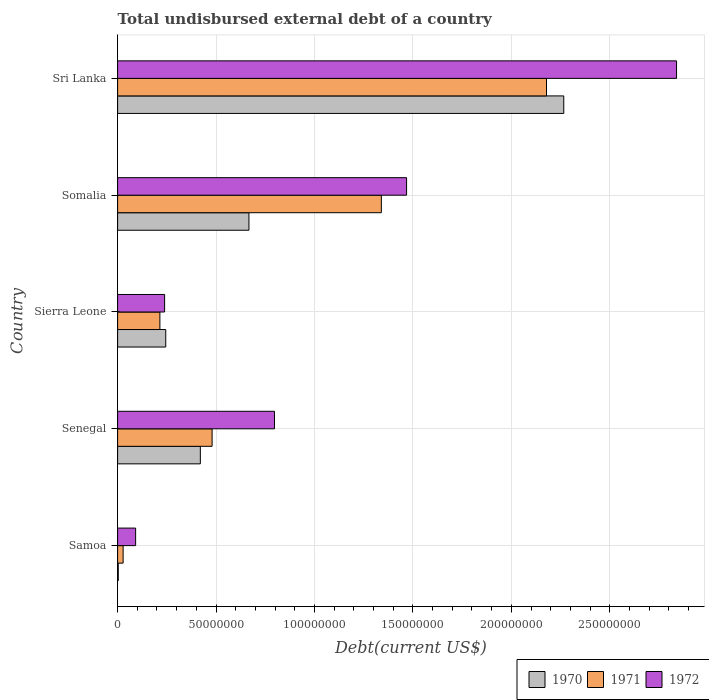How many different coloured bars are there?
Offer a terse response. 3. How many groups of bars are there?
Keep it short and to the point. 5. Are the number of bars per tick equal to the number of legend labels?
Give a very brief answer. Yes. Are the number of bars on each tick of the Y-axis equal?
Your answer should be compact. Yes. How many bars are there on the 5th tick from the top?
Ensure brevity in your answer.  3. What is the label of the 2nd group of bars from the top?
Offer a very short reply. Somalia. What is the total undisbursed external debt in 1970 in Samoa?
Your answer should be compact. 3.36e+05. Across all countries, what is the maximum total undisbursed external debt in 1971?
Provide a succinct answer. 2.18e+08. Across all countries, what is the minimum total undisbursed external debt in 1972?
Make the answer very short. 9.15e+06. In which country was the total undisbursed external debt in 1970 maximum?
Provide a short and direct response. Sri Lanka. In which country was the total undisbursed external debt in 1970 minimum?
Provide a succinct answer. Samoa. What is the total total undisbursed external debt in 1971 in the graph?
Offer a terse response. 4.24e+08. What is the difference between the total undisbursed external debt in 1970 in Samoa and that in Somalia?
Make the answer very short. -6.64e+07. What is the difference between the total undisbursed external debt in 1971 in Somalia and the total undisbursed external debt in 1972 in Senegal?
Provide a short and direct response. 5.43e+07. What is the average total undisbursed external debt in 1970 per country?
Provide a short and direct response. 7.20e+07. What is the difference between the total undisbursed external debt in 1971 and total undisbursed external debt in 1972 in Somalia?
Provide a short and direct response. -1.28e+07. In how many countries, is the total undisbursed external debt in 1971 greater than 170000000 US$?
Ensure brevity in your answer.  1. What is the ratio of the total undisbursed external debt in 1971 in Senegal to that in Sri Lanka?
Ensure brevity in your answer.  0.22. Is the total undisbursed external debt in 1971 in Samoa less than that in Sierra Leone?
Keep it short and to the point. Yes. Is the difference between the total undisbursed external debt in 1971 in Senegal and Sierra Leone greater than the difference between the total undisbursed external debt in 1972 in Senegal and Sierra Leone?
Ensure brevity in your answer.  No. What is the difference between the highest and the second highest total undisbursed external debt in 1972?
Keep it short and to the point. 1.37e+08. What is the difference between the highest and the lowest total undisbursed external debt in 1971?
Your answer should be compact. 2.15e+08. Is the sum of the total undisbursed external debt in 1970 in Samoa and Senegal greater than the maximum total undisbursed external debt in 1971 across all countries?
Provide a succinct answer. No. Is it the case that in every country, the sum of the total undisbursed external debt in 1970 and total undisbursed external debt in 1972 is greater than the total undisbursed external debt in 1971?
Ensure brevity in your answer.  Yes. How many countries are there in the graph?
Provide a succinct answer. 5. What is the difference between two consecutive major ticks on the X-axis?
Your answer should be very brief. 5.00e+07. Does the graph contain any zero values?
Your answer should be very brief. No. Does the graph contain grids?
Your answer should be compact. Yes. How many legend labels are there?
Give a very brief answer. 3. What is the title of the graph?
Give a very brief answer. Total undisbursed external debt of a country. What is the label or title of the X-axis?
Offer a terse response. Debt(current US$). What is the label or title of the Y-axis?
Provide a short and direct response. Country. What is the Debt(current US$) in 1970 in Samoa?
Your answer should be compact. 3.36e+05. What is the Debt(current US$) in 1971 in Samoa?
Your response must be concise. 2.80e+06. What is the Debt(current US$) in 1972 in Samoa?
Give a very brief answer. 9.15e+06. What is the Debt(current US$) in 1970 in Senegal?
Keep it short and to the point. 4.20e+07. What is the Debt(current US$) in 1971 in Senegal?
Make the answer very short. 4.80e+07. What is the Debt(current US$) in 1972 in Senegal?
Provide a succinct answer. 7.97e+07. What is the Debt(current US$) of 1970 in Sierra Leone?
Provide a succinct answer. 2.45e+07. What is the Debt(current US$) of 1971 in Sierra Leone?
Your answer should be very brief. 2.15e+07. What is the Debt(current US$) of 1972 in Sierra Leone?
Your answer should be very brief. 2.39e+07. What is the Debt(current US$) of 1970 in Somalia?
Offer a terse response. 6.67e+07. What is the Debt(current US$) in 1971 in Somalia?
Offer a very short reply. 1.34e+08. What is the Debt(current US$) in 1972 in Somalia?
Make the answer very short. 1.47e+08. What is the Debt(current US$) of 1970 in Sri Lanka?
Your response must be concise. 2.27e+08. What is the Debt(current US$) of 1971 in Sri Lanka?
Keep it short and to the point. 2.18e+08. What is the Debt(current US$) of 1972 in Sri Lanka?
Provide a short and direct response. 2.84e+08. Across all countries, what is the maximum Debt(current US$) of 1970?
Offer a terse response. 2.27e+08. Across all countries, what is the maximum Debt(current US$) of 1971?
Ensure brevity in your answer.  2.18e+08. Across all countries, what is the maximum Debt(current US$) of 1972?
Provide a short and direct response. 2.84e+08. Across all countries, what is the minimum Debt(current US$) in 1970?
Your answer should be very brief. 3.36e+05. Across all countries, what is the minimum Debt(current US$) in 1971?
Your answer should be very brief. 2.80e+06. Across all countries, what is the minimum Debt(current US$) in 1972?
Offer a terse response. 9.15e+06. What is the total Debt(current US$) of 1970 in the graph?
Ensure brevity in your answer.  3.60e+08. What is the total Debt(current US$) of 1971 in the graph?
Provide a succinct answer. 4.24e+08. What is the total Debt(current US$) in 1972 in the graph?
Offer a terse response. 5.43e+08. What is the difference between the Debt(current US$) in 1970 in Samoa and that in Senegal?
Offer a terse response. -4.17e+07. What is the difference between the Debt(current US$) in 1971 in Samoa and that in Senegal?
Provide a succinct answer. -4.52e+07. What is the difference between the Debt(current US$) of 1972 in Samoa and that in Senegal?
Your answer should be compact. -7.05e+07. What is the difference between the Debt(current US$) in 1970 in Samoa and that in Sierra Leone?
Give a very brief answer. -2.41e+07. What is the difference between the Debt(current US$) of 1971 in Samoa and that in Sierra Leone?
Ensure brevity in your answer.  -1.87e+07. What is the difference between the Debt(current US$) in 1972 in Samoa and that in Sierra Leone?
Offer a very short reply. -1.47e+07. What is the difference between the Debt(current US$) in 1970 in Samoa and that in Somalia?
Provide a short and direct response. -6.64e+07. What is the difference between the Debt(current US$) in 1971 in Samoa and that in Somalia?
Provide a succinct answer. -1.31e+08. What is the difference between the Debt(current US$) in 1972 in Samoa and that in Somalia?
Ensure brevity in your answer.  -1.38e+08. What is the difference between the Debt(current US$) in 1970 in Samoa and that in Sri Lanka?
Make the answer very short. -2.26e+08. What is the difference between the Debt(current US$) in 1971 in Samoa and that in Sri Lanka?
Keep it short and to the point. -2.15e+08. What is the difference between the Debt(current US$) of 1972 in Samoa and that in Sri Lanka?
Provide a succinct answer. -2.75e+08. What is the difference between the Debt(current US$) of 1970 in Senegal and that in Sierra Leone?
Offer a terse response. 1.76e+07. What is the difference between the Debt(current US$) of 1971 in Senegal and that in Sierra Leone?
Your answer should be compact. 2.65e+07. What is the difference between the Debt(current US$) of 1972 in Senegal and that in Sierra Leone?
Offer a terse response. 5.58e+07. What is the difference between the Debt(current US$) in 1970 in Senegal and that in Somalia?
Your response must be concise. -2.47e+07. What is the difference between the Debt(current US$) in 1971 in Senegal and that in Somalia?
Offer a very short reply. -8.60e+07. What is the difference between the Debt(current US$) of 1972 in Senegal and that in Somalia?
Provide a succinct answer. -6.71e+07. What is the difference between the Debt(current US$) in 1970 in Senegal and that in Sri Lanka?
Your response must be concise. -1.85e+08. What is the difference between the Debt(current US$) in 1971 in Senegal and that in Sri Lanka?
Your answer should be very brief. -1.70e+08. What is the difference between the Debt(current US$) of 1972 in Senegal and that in Sri Lanka?
Provide a succinct answer. -2.04e+08. What is the difference between the Debt(current US$) in 1970 in Sierra Leone and that in Somalia?
Give a very brief answer. -4.23e+07. What is the difference between the Debt(current US$) of 1971 in Sierra Leone and that in Somalia?
Your answer should be compact. -1.12e+08. What is the difference between the Debt(current US$) in 1972 in Sierra Leone and that in Somalia?
Give a very brief answer. -1.23e+08. What is the difference between the Debt(current US$) in 1970 in Sierra Leone and that in Sri Lanka?
Ensure brevity in your answer.  -2.02e+08. What is the difference between the Debt(current US$) in 1971 in Sierra Leone and that in Sri Lanka?
Make the answer very short. -1.96e+08. What is the difference between the Debt(current US$) in 1972 in Sierra Leone and that in Sri Lanka?
Make the answer very short. -2.60e+08. What is the difference between the Debt(current US$) of 1970 in Somalia and that in Sri Lanka?
Your answer should be compact. -1.60e+08. What is the difference between the Debt(current US$) in 1971 in Somalia and that in Sri Lanka?
Your response must be concise. -8.39e+07. What is the difference between the Debt(current US$) of 1972 in Somalia and that in Sri Lanka?
Ensure brevity in your answer.  -1.37e+08. What is the difference between the Debt(current US$) of 1970 in Samoa and the Debt(current US$) of 1971 in Senegal?
Offer a terse response. -4.77e+07. What is the difference between the Debt(current US$) in 1970 in Samoa and the Debt(current US$) in 1972 in Senegal?
Provide a succinct answer. -7.93e+07. What is the difference between the Debt(current US$) of 1971 in Samoa and the Debt(current US$) of 1972 in Senegal?
Provide a succinct answer. -7.69e+07. What is the difference between the Debt(current US$) of 1970 in Samoa and the Debt(current US$) of 1971 in Sierra Leone?
Keep it short and to the point. -2.11e+07. What is the difference between the Debt(current US$) of 1970 in Samoa and the Debt(current US$) of 1972 in Sierra Leone?
Keep it short and to the point. -2.35e+07. What is the difference between the Debt(current US$) in 1971 in Samoa and the Debt(current US$) in 1972 in Sierra Leone?
Ensure brevity in your answer.  -2.11e+07. What is the difference between the Debt(current US$) of 1970 in Samoa and the Debt(current US$) of 1971 in Somalia?
Offer a terse response. -1.34e+08. What is the difference between the Debt(current US$) in 1970 in Samoa and the Debt(current US$) in 1972 in Somalia?
Your response must be concise. -1.46e+08. What is the difference between the Debt(current US$) of 1971 in Samoa and the Debt(current US$) of 1972 in Somalia?
Ensure brevity in your answer.  -1.44e+08. What is the difference between the Debt(current US$) in 1970 in Samoa and the Debt(current US$) in 1971 in Sri Lanka?
Ensure brevity in your answer.  -2.18e+08. What is the difference between the Debt(current US$) in 1970 in Samoa and the Debt(current US$) in 1972 in Sri Lanka?
Offer a very short reply. -2.84e+08. What is the difference between the Debt(current US$) in 1971 in Samoa and the Debt(current US$) in 1972 in Sri Lanka?
Your answer should be very brief. -2.81e+08. What is the difference between the Debt(current US$) in 1970 in Senegal and the Debt(current US$) in 1971 in Sierra Leone?
Make the answer very short. 2.05e+07. What is the difference between the Debt(current US$) of 1970 in Senegal and the Debt(current US$) of 1972 in Sierra Leone?
Your answer should be compact. 1.82e+07. What is the difference between the Debt(current US$) of 1971 in Senegal and the Debt(current US$) of 1972 in Sierra Leone?
Offer a very short reply. 2.41e+07. What is the difference between the Debt(current US$) of 1970 in Senegal and the Debt(current US$) of 1971 in Somalia?
Offer a terse response. -9.19e+07. What is the difference between the Debt(current US$) of 1970 in Senegal and the Debt(current US$) of 1972 in Somalia?
Keep it short and to the point. -1.05e+08. What is the difference between the Debt(current US$) in 1971 in Senegal and the Debt(current US$) in 1972 in Somalia?
Ensure brevity in your answer.  -9.88e+07. What is the difference between the Debt(current US$) of 1970 in Senegal and the Debt(current US$) of 1971 in Sri Lanka?
Provide a short and direct response. -1.76e+08. What is the difference between the Debt(current US$) of 1970 in Senegal and the Debt(current US$) of 1972 in Sri Lanka?
Provide a short and direct response. -2.42e+08. What is the difference between the Debt(current US$) in 1971 in Senegal and the Debt(current US$) in 1972 in Sri Lanka?
Offer a terse response. -2.36e+08. What is the difference between the Debt(current US$) in 1970 in Sierra Leone and the Debt(current US$) in 1971 in Somalia?
Make the answer very short. -1.10e+08. What is the difference between the Debt(current US$) of 1970 in Sierra Leone and the Debt(current US$) of 1972 in Somalia?
Your answer should be compact. -1.22e+08. What is the difference between the Debt(current US$) in 1971 in Sierra Leone and the Debt(current US$) in 1972 in Somalia?
Offer a terse response. -1.25e+08. What is the difference between the Debt(current US$) of 1970 in Sierra Leone and the Debt(current US$) of 1971 in Sri Lanka?
Offer a very short reply. -1.93e+08. What is the difference between the Debt(current US$) in 1970 in Sierra Leone and the Debt(current US$) in 1972 in Sri Lanka?
Give a very brief answer. -2.59e+08. What is the difference between the Debt(current US$) in 1971 in Sierra Leone and the Debt(current US$) in 1972 in Sri Lanka?
Give a very brief answer. -2.62e+08. What is the difference between the Debt(current US$) in 1970 in Somalia and the Debt(current US$) in 1971 in Sri Lanka?
Offer a very short reply. -1.51e+08. What is the difference between the Debt(current US$) of 1970 in Somalia and the Debt(current US$) of 1972 in Sri Lanka?
Make the answer very short. -2.17e+08. What is the difference between the Debt(current US$) in 1971 in Somalia and the Debt(current US$) in 1972 in Sri Lanka?
Your response must be concise. -1.50e+08. What is the average Debt(current US$) in 1970 per country?
Give a very brief answer. 7.20e+07. What is the average Debt(current US$) of 1971 per country?
Your answer should be very brief. 8.48e+07. What is the average Debt(current US$) in 1972 per country?
Offer a terse response. 1.09e+08. What is the difference between the Debt(current US$) of 1970 and Debt(current US$) of 1971 in Samoa?
Your response must be concise. -2.46e+06. What is the difference between the Debt(current US$) in 1970 and Debt(current US$) in 1972 in Samoa?
Provide a short and direct response. -8.82e+06. What is the difference between the Debt(current US$) in 1971 and Debt(current US$) in 1972 in Samoa?
Offer a terse response. -6.35e+06. What is the difference between the Debt(current US$) of 1970 and Debt(current US$) of 1971 in Senegal?
Offer a very short reply. -5.97e+06. What is the difference between the Debt(current US$) of 1970 and Debt(current US$) of 1972 in Senegal?
Make the answer very short. -3.77e+07. What is the difference between the Debt(current US$) of 1971 and Debt(current US$) of 1972 in Senegal?
Provide a short and direct response. -3.17e+07. What is the difference between the Debt(current US$) of 1970 and Debt(current US$) of 1971 in Sierra Leone?
Your answer should be very brief. 2.98e+06. What is the difference between the Debt(current US$) in 1970 and Debt(current US$) in 1972 in Sierra Leone?
Make the answer very short. 5.82e+05. What is the difference between the Debt(current US$) of 1971 and Debt(current US$) of 1972 in Sierra Leone?
Provide a short and direct response. -2.40e+06. What is the difference between the Debt(current US$) of 1970 and Debt(current US$) of 1971 in Somalia?
Provide a short and direct response. -6.73e+07. What is the difference between the Debt(current US$) in 1970 and Debt(current US$) in 1972 in Somalia?
Your answer should be compact. -8.01e+07. What is the difference between the Debt(current US$) of 1971 and Debt(current US$) of 1972 in Somalia?
Offer a terse response. -1.28e+07. What is the difference between the Debt(current US$) in 1970 and Debt(current US$) in 1971 in Sri Lanka?
Offer a very short reply. 8.78e+06. What is the difference between the Debt(current US$) of 1970 and Debt(current US$) of 1972 in Sri Lanka?
Ensure brevity in your answer.  -5.73e+07. What is the difference between the Debt(current US$) of 1971 and Debt(current US$) of 1972 in Sri Lanka?
Provide a succinct answer. -6.61e+07. What is the ratio of the Debt(current US$) in 1970 in Samoa to that in Senegal?
Provide a succinct answer. 0.01. What is the ratio of the Debt(current US$) of 1971 in Samoa to that in Senegal?
Your response must be concise. 0.06. What is the ratio of the Debt(current US$) in 1972 in Samoa to that in Senegal?
Keep it short and to the point. 0.11. What is the ratio of the Debt(current US$) in 1970 in Samoa to that in Sierra Leone?
Your response must be concise. 0.01. What is the ratio of the Debt(current US$) in 1971 in Samoa to that in Sierra Leone?
Offer a terse response. 0.13. What is the ratio of the Debt(current US$) of 1972 in Samoa to that in Sierra Leone?
Make the answer very short. 0.38. What is the ratio of the Debt(current US$) of 1970 in Samoa to that in Somalia?
Provide a succinct answer. 0.01. What is the ratio of the Debt(current US$) of 1971 in Samoa to that in Somalia?
Provide a succinct answer. 0.02. What is the ratio of the Debt(current US$) in 1972 in Samoa to that in Somalia?
Provide a short and direct response. 0.06. What is the ratio of the Debt(current US$) in 1970 in Samoa to that in Sri Lanka?
Your answer should be compact. 0. What is the ratio of the Debt(current US$) of 1971 in Samoa to that in Sri Lanka?
Provide a short and direct response. 0.01. What is the ratio of the Debt(current US$) of 1972 in Samoa to that in Sri Lanka?
Your answer should be very brief. 0.03. What is the ratio of the Debt(current US$) of 1970 in Senegal to that in Sierra Leone?
Your answer should be compact. 1.72. What is the ratio of the Debt(current US$) in 1971 in Senegal to that in Sierra Leone?
Your answer should be compact. 2.23. What is the ratio of the Debt(current US$) in 1972 in Senegal to that in Sierra Leone?
Make the answer very short. 3.34. What is the ratio of the Debt(current US$) of 1970 in Senegal to that in Somalia?
Give a very brief answer. 0.63. What is the ratio of the Debt(current US$) of 1971 in Senegal to that in Somalia?
Your answer should be compact. 0.36. What is the ratio of the Debt(current US$) in 1972 in Senegal to that in Somalia?
Offer a very short reply. 0.54. What is the ratio of the Debt(current US$) in 1970 in Senegal to that in Sri Lanka?
Keep it short and to the point. 0.19. What is the ratio of the Debt(current US$) in 1971 in Senegal to that in Sri Lanka?
Give a very brief answer. 0.22. What is the ratio of the Debt(current US$) in 1972 in Senegal to that in Sri Lanka?
Keep it short and to the point. 0.28. What is the ratio of the Debt(current US$) of 1970 in Sierra Leone to that in Somalia?
Keep it short and to the point. 0.37. What is the ratio of the Debt(current US$) of 1971 in Sierra Leone to that in Somalia?
Give a very brief answer. 0.16. What is the ratio of the Debt(current US$) of 1972 in Sierra Leone to that in Somalia?
Provide a short and direct response. 0.16. What is the ratio of the Debt(current US$) in 1970 in Sierra Leone to that in Sri Lanka?
Your answer should be compact. 0.11. What is the ratio of the Debt(current US$) of 1971 in Sierra Leone to that in Sri Lanka?
Ensure brevity in your answer.  0.1. What is the ratio of the Debt(current US$) in 1972 in Sierra Leone to that in Sri Lanka?
Make the answer very short. 0.08. What is the ratio of the Debt(current US$) in 1970 in Somalia to that in Sri Lanka?
Provide a succinct answer. 0.29. What is the ratio of the Debt(current US$) in 1971 in Somalia to that in Sri Lanka?
Provide a short and direct response. 0.61. What is the ratio of the Debt(current US$) in 1972 in Somalia to that in Sri Lanka?
Your answer should be very brief. 0.52. What is the difference between the highest and the second highest Debt(current US$) of 1970?
Your response must be concise. 1.60e+08. What is the difference between the highest and the second highest Debt(current US$) in 1971?
Keep it short and to the point. 8.39e+07. What is the difference between the highest and the second highest Debt(current US$) in 1972?
Offer a terse response. 1.37e+08. What is the difference between the highest and the lowest Debt(current US$) of 1970?
Keep it short and to the point. 2.26e+08. What is the difference between the highest and the lowest Debt(current US$) in 1971?
Provide a short and direct response. 2.15e+08. What is the difference between the highest and the lowest Debt(current US$) of 1972?
Offer a very short reply. 2.75e+08. 